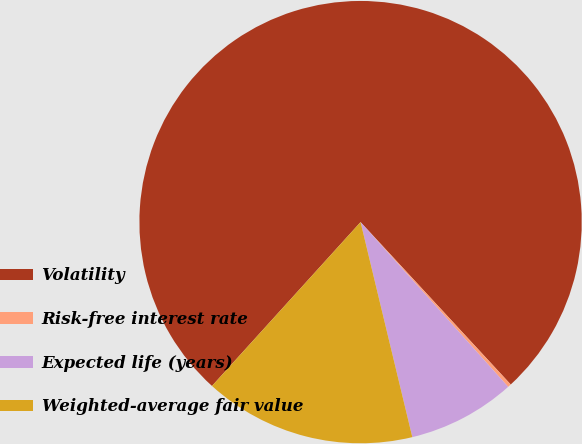Convert chart. <chart><loc_0><loc_0><loc_500><loc_500><pie_chart><fcel>Volatility<fcel>Risk-free interest rate<fcel>Expected life (years)<fcel>Weighted-average fair value<nl><fcel>76.39%<fcel>0.25%<fcel>7.87%<fcel>15.48%<nl></chart> 